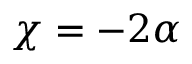<formula> <loc_0><loc_0><loc_500><loc_500>\chi = - 2 \alpha</formula> 